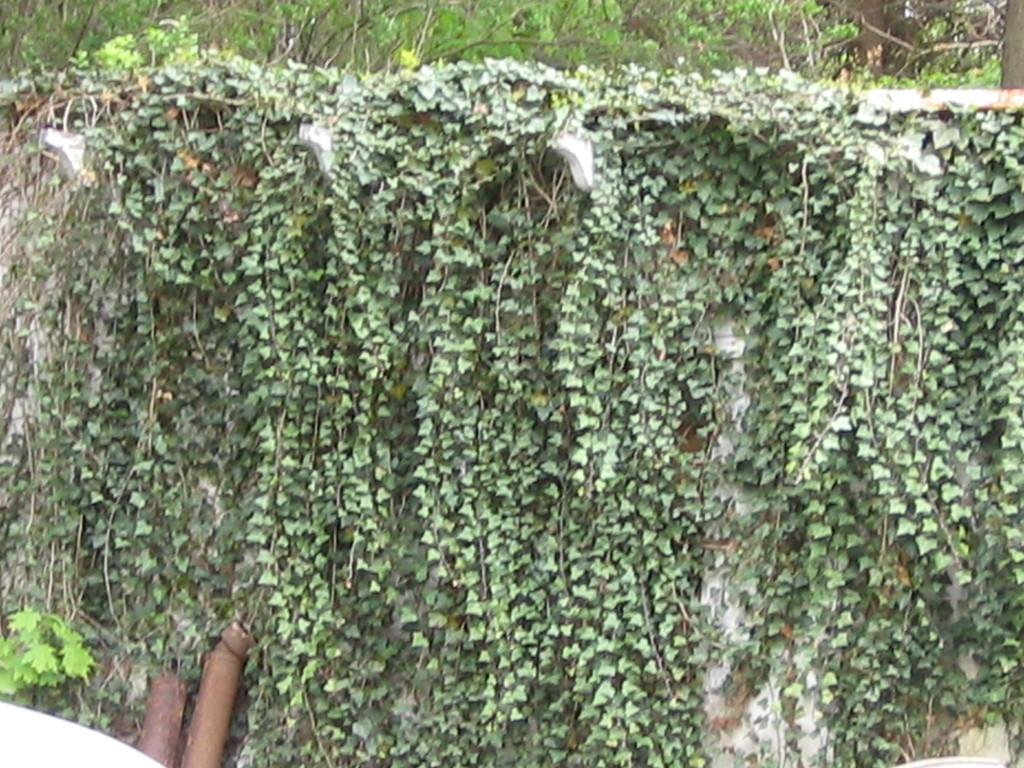What type of living organisms can be seen in the image? Plants can be seen in the image. Can you tell me what book your aunt is reading in the image? There is no book or aunt present in the image; it only features plants. 